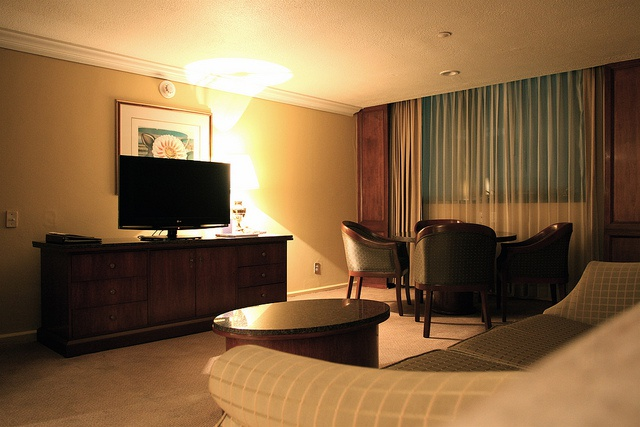Describe the objects in this image and their specific colors. I can see couch in olive, tan, and maroon tones, dining table in olive, black, maroon, and brown tones, tv in olive, black, and gray tones, chair in olive, black, brown, and maroon tones, and chair in olive, black, maroon, and brown tones in this image. 